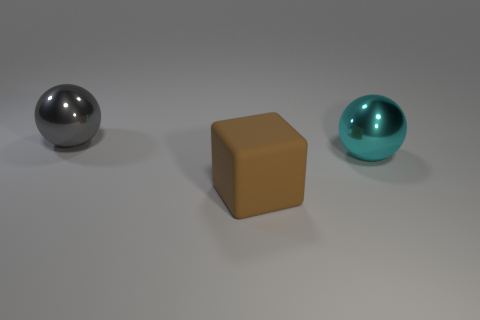Subtract all blocks. How many objects are left? 2 Subtract 1 spheres. How many spheres are left? 1 Subtract all red blocks. Subtract all yellow spheres. How many blocks are left? 1 Subtract all red blocks. How many brown balls are left? 0 Subtract all spheres. Subtract all cyan spheres. How many objects are left? 0 Add 1 large metallic spheres. How many large metallic spheres are left? 3 Add 2 large brown rubber objects. How many large brown rubber objects exist? 3 Add 1 large gray spheres. How many objects exist? 4 Subtract all gray spheres. How many spheres are left? 1 Subtract 0 green cylinders. How many objects are left? 3 